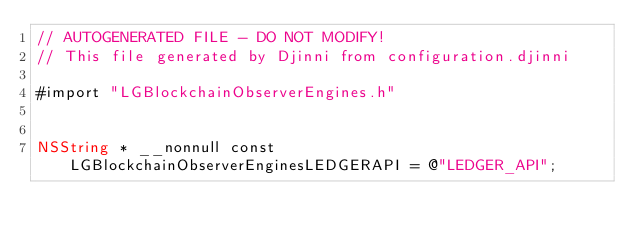Convert code to text. <code><loc_0><loc_0><loc_500><loc_500><_ObjectiveC_>// AUTOGENERATED FILE - DO NOT MODIFY!
// This file generated by Djinni from configuration.djinni

#import "LGBlockchainObserverEngines.h"


NSString * __nonnull const LGBlockchainObserverEnginesLEDGERAPI = @"LEDGER_API";
</code> 